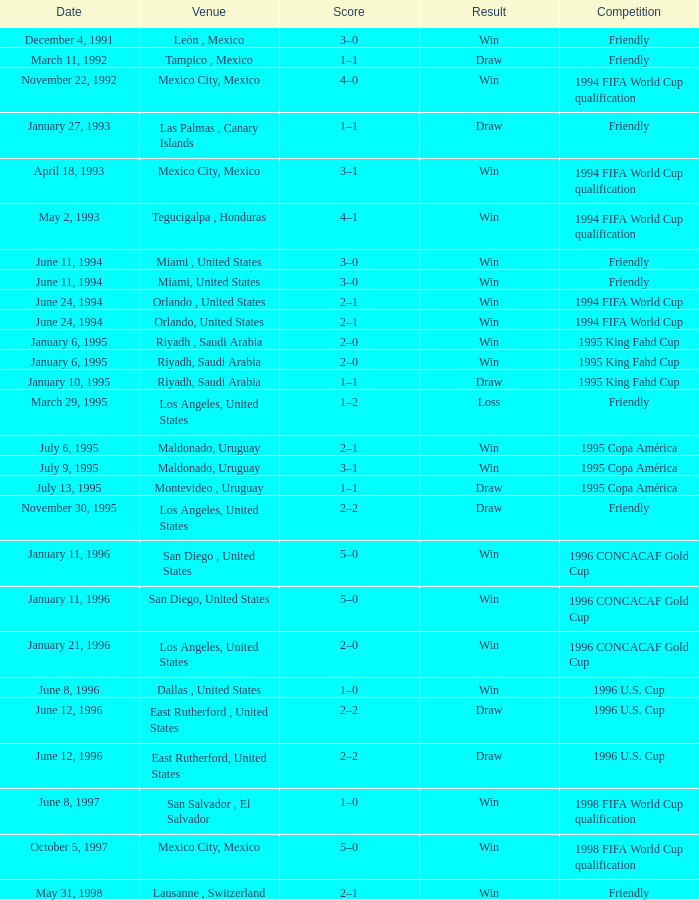If the date is "june 11, 1994" and the location is "miami, united states," what is the consequence? Win, Win. Would you mind parsing the complete table? {'header': ['Date', 'Venue', 'Score', 'Result', 'Competition'], 'rows': [['December 4, 1991', 'León , Mexico', '3–0', 'Win', 'Friendly'], ['March 11, 1992', 'Tampico , Mexico', '1–1', 'Draw', 'Friendly'], ['November 22, 1992', 'Mexico City, Mexico', '4–0', 'Win', '1994 FIFA World Cup qualification'], ['January 27, 1993', 'Las Palmas , Canary Islands', '1–1', 'Draw', 'Friendly'], ['April 18, 1993', 'Mexico City, Mexico', '3–1', 'Win', '1994 FIFA World Cup qualification'], ['May 2, 1993', 'Tegucigalpa , Honduras', '4–1', 'Win', '1994 FIFA World Cup qualification'], ['June 11, 1994', 'Miami , United States', '3–0', 'Win', 'Friendly'], ['June 11, 1994', 'Miami, United States', '3–0', 'Win', 'Friendly'], ['June 24, 1994', 'Orlando , United States', '2–1', 'Win', '1994 FIFA World Cup'], ['June 24, 1994', 'Orlando, United States', '2–1', 'Win', '1994 FIFA World Cup'], ['January 6, 1995', 'Riyadh , Saudi Arabia', '2–0', 'Win', '1995 King Fahd Cup'], ['January 6, 1995', 'Riyadh, Saudi Arabia', '2–0', 'Win', '1995 King Fahd Cup'], ['January 10, 1995', 'Riyadh, Saudi Arabia', '1–1', 'Draw', '1995 King Fahd Cup'], ['March 29, 1995', 'Los Angeles, United States', '1–2', 'Loss', 'Friendly'], ['July 6, 1995', 'Maldonado, Uruguay', '2–1', 'Win', '1995 Copa América'], ['July 9, 1995', 'Maldonado, Uruguay', '3–1', 'Win', '1995 Copa América'], ['July 13, 1995', 'Montevideo , Uruguay', '1–1', 'Draw', '1995 Copa América'], ['November 30, 1995', 'Los Angeles, United States', '2–2', 'Draw', 'Friendly'], ['January 11, 1996', 'San Diego , United States', '5–0', 'Win', '1996 CONCACAF Gold Cup'], ['January 11, 1996', 'San Diego, United States', '5–0', 'Win', '1996 CONCACAF Gold Cup'], ['January 21, 1996', 'Los Angeles, United States', '2–0', 'Win', '1996 CONCACAF Gold Cup'], ['June 8, 1996', 'Dallas , United States', '1–0', 'Win', '1996 U.S. Cup'], ['June 12, 1996', 'East Rutherford , United States', '2–2', 'Draw', '1996 U.S. Cup'], ['June 12, 1996', 'East Rutherford, United States', '2–2', 'Draw', '1996 U.S. Cup'], ['June 8, 1997', 'San Salvador , El Salvador', '1–0', 'Win', '1998 FIFA World Cup qualification'], ['October 5, 1997', 'Mexico City, Mexico', '5–0', 'Win', '1998 FIFA World Cup qualification'], ['May 31, 1998', 'Lausanne , Switzerland', '2–1', 'Win', 'Friendly']]} 